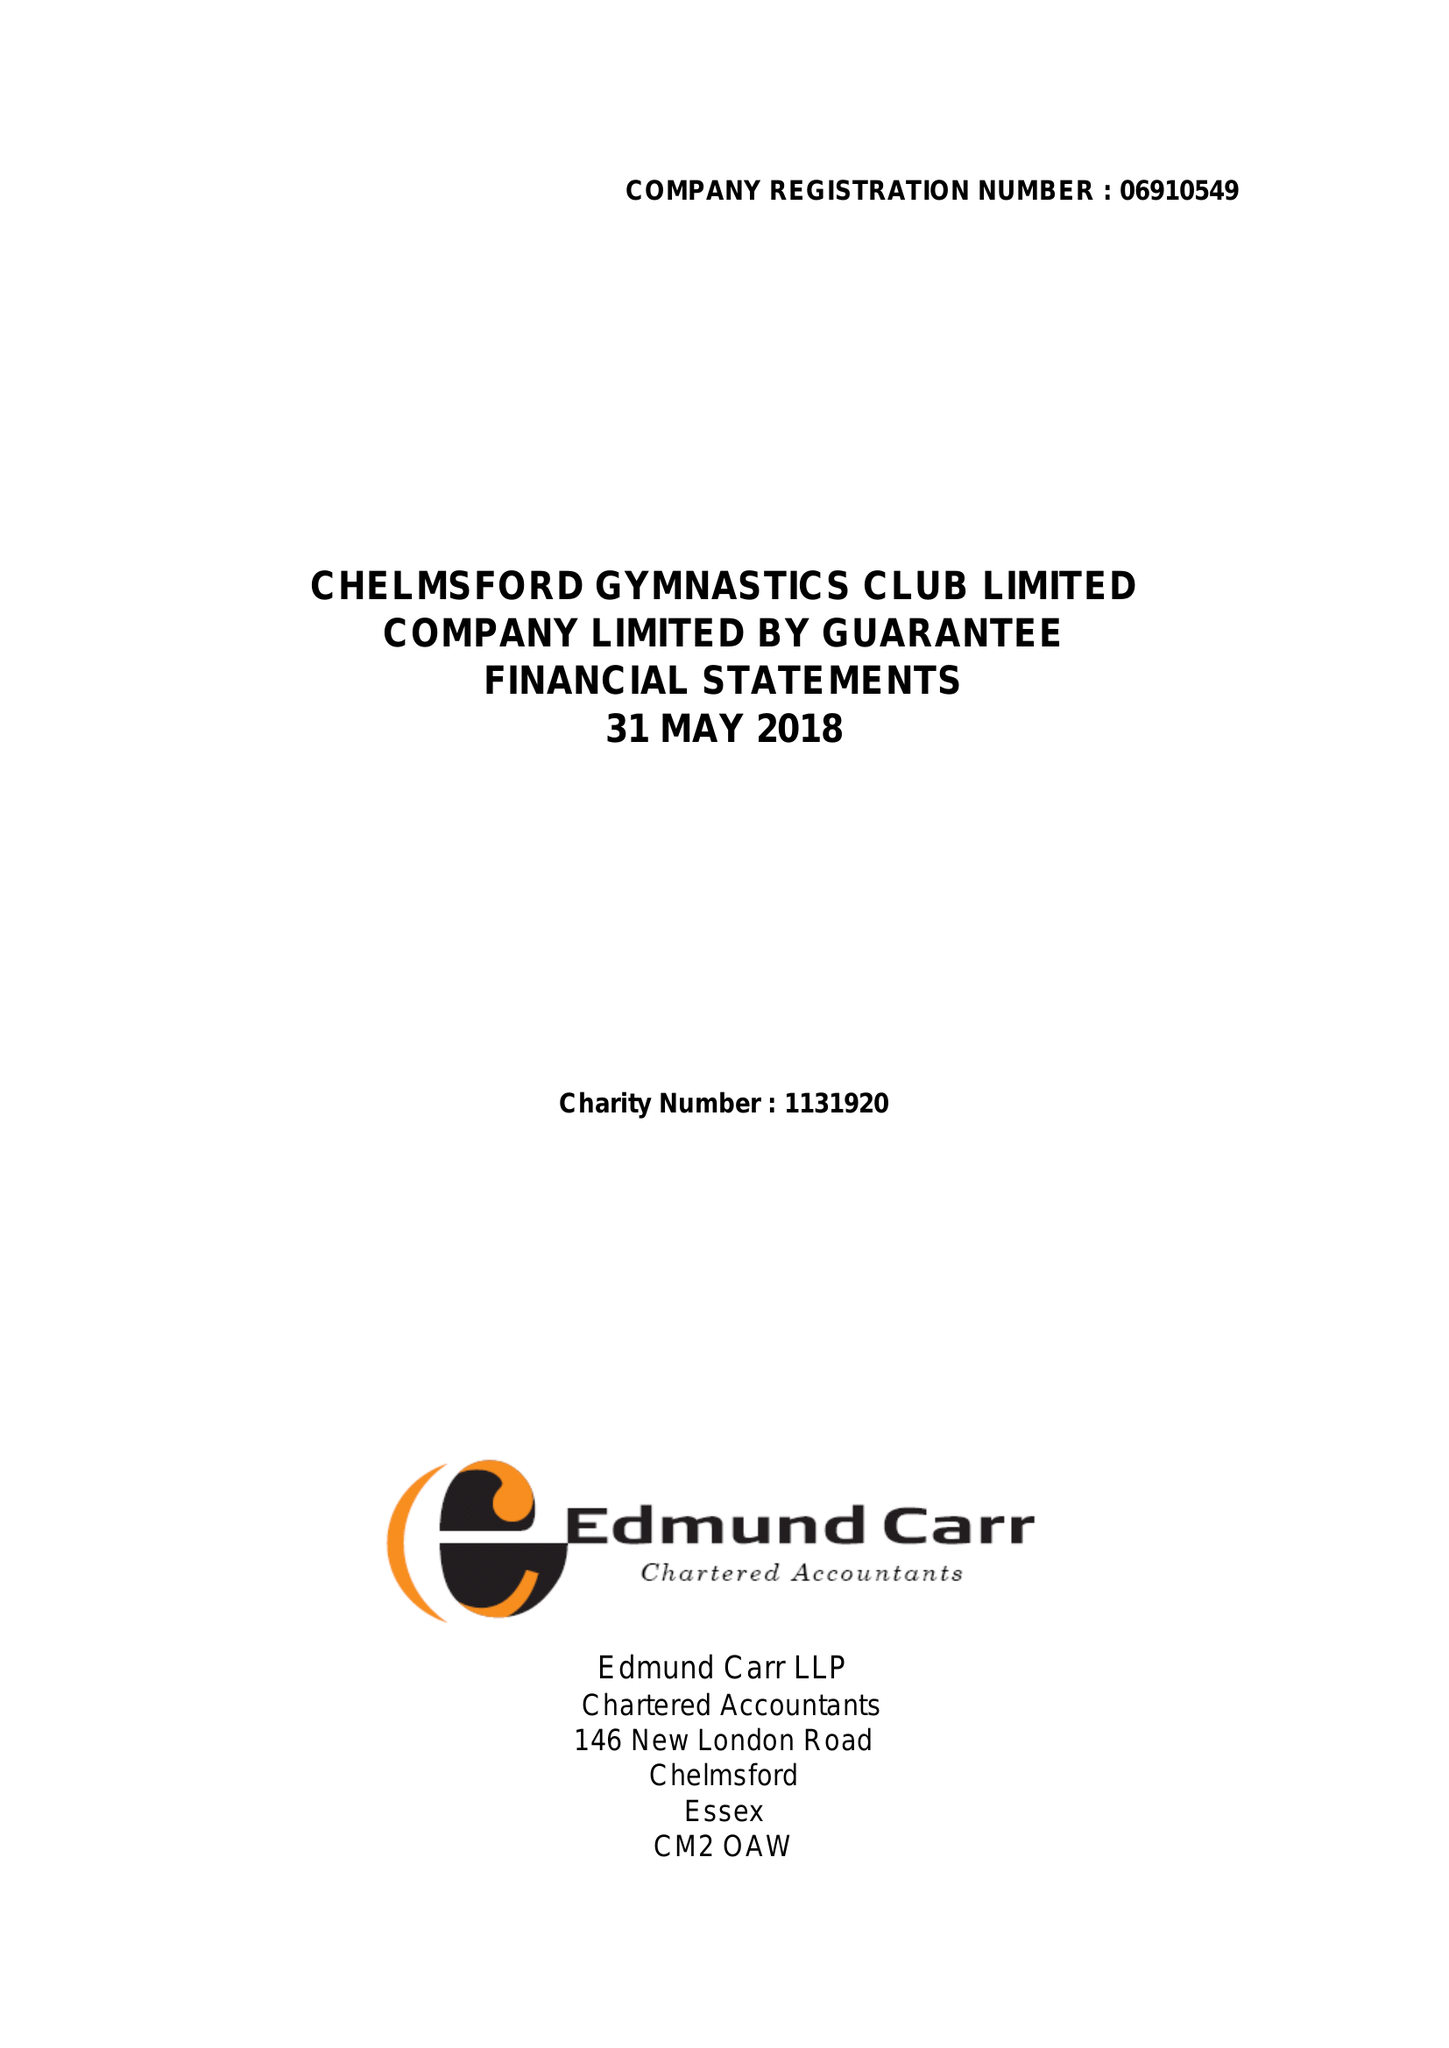What is the value for the report_date?
Answer the question using a single word or phrase. 2018-05-31 